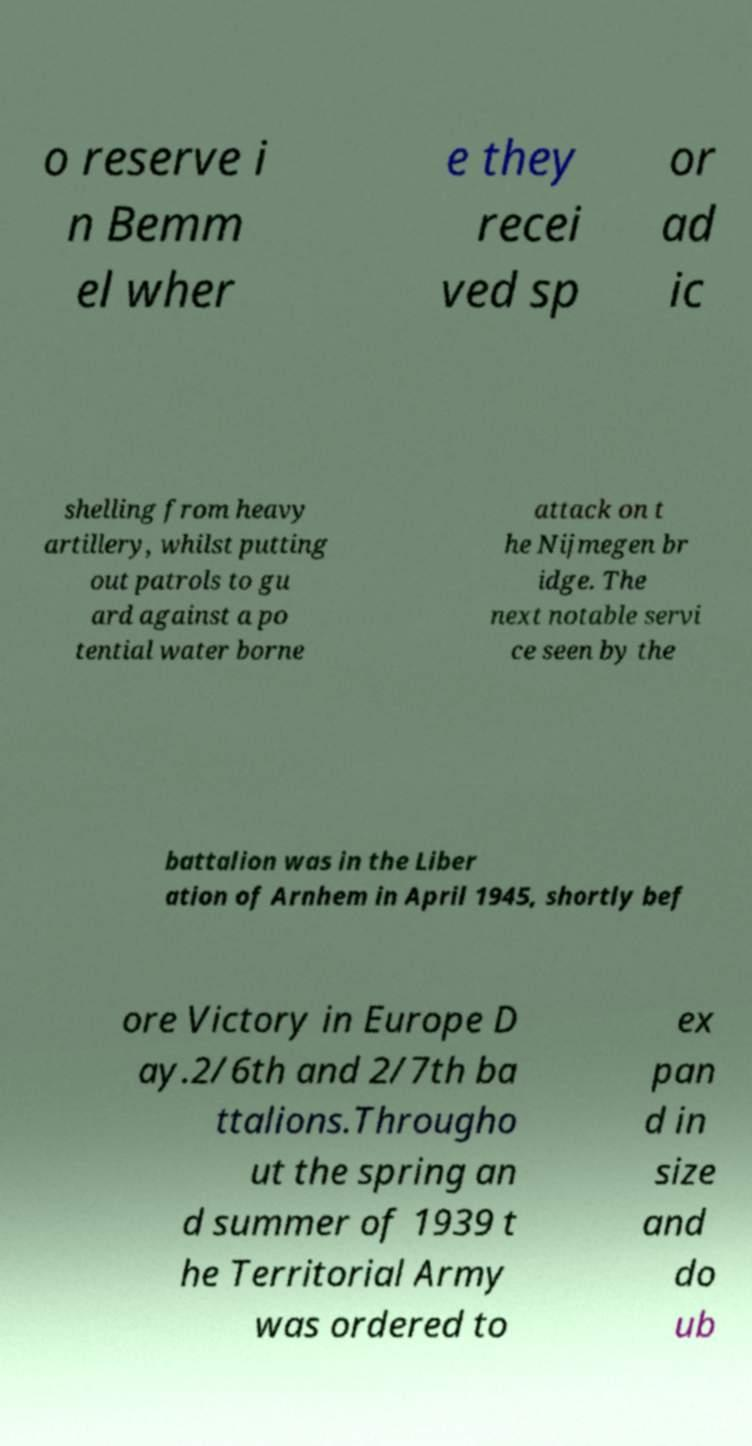Please read and relay the text visible in this image. What does it say? o reserve i n Bemm el wher e they recei ved sp or ad ic shelling from heavy artillery, whilst putting out patrols to gu ard against a po tential water borne attack on t he Nijmegen br idge. The next notable servi ce seen by the battalion was in the Liber ation of Arnhem in April 1945, shortly bef ore Victory in Europe D ay.2/6th and 2/7th ba ttalions.Througho ut the spring an d summer of 1939 t he Territorial Army was ordered to ex pan d in size and do ub 